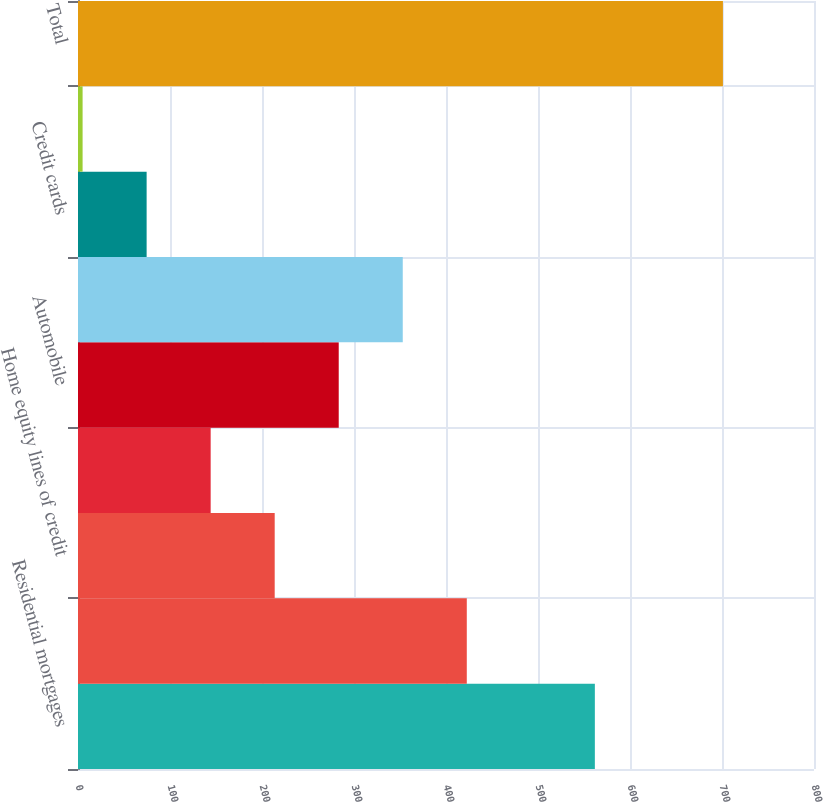<chart> <loc_0><loc_0><loc_500><loc_500><bar_chart><fcel>Residential mortgages<fcel>Home equity loans<fcel>Home equity lines of credit<fcel>Home equity loans serviced by<fcel>Automobile<fcel>Student<fcel>Credit cards<fcel>Other retail<fcel>Total<nl><fcel>561.8<fcel>422.6<fcel>213.8<fcel>144.2<fcel>283.4<fcel>353<fcel>74.6<fcel>5<fcel>701<nl></chart> 